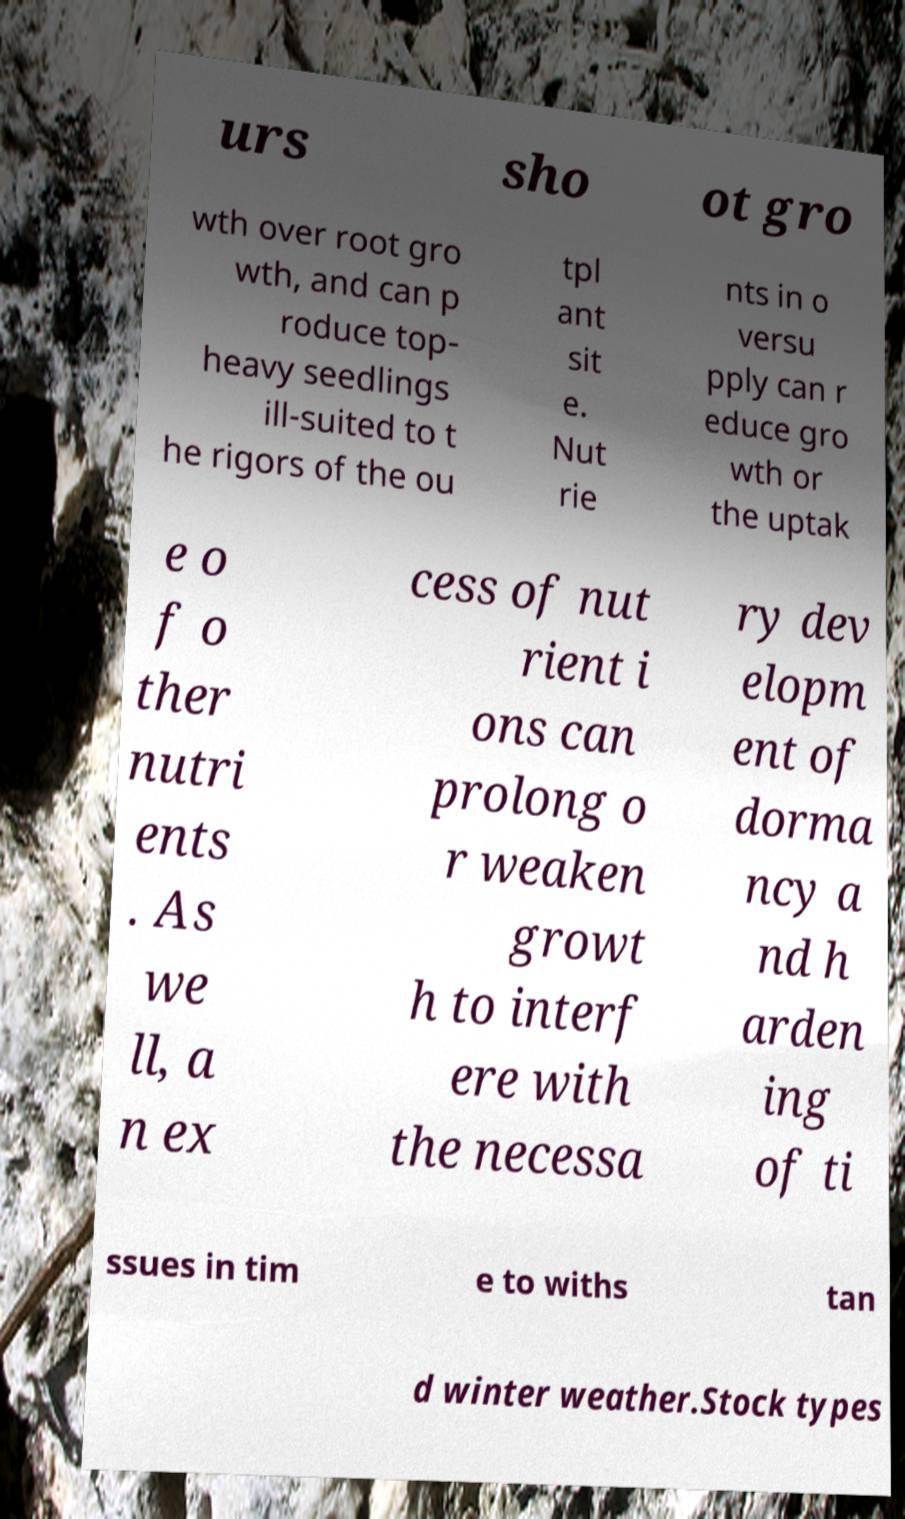I need the written content from this picture converted into text. Can you do that? urs sho ot gro wth over root gro wth, and can p roduce top- heavy seedlings ill-suited to t he rigors of the ou tpl ant sit e. Nut rie nts in o versu pply can r educe gro wth or the uptak e o f o ther nutri ents . As we ll, a n ex cess of nut rient i ons can prolong o r weaken growt h to interf ere with the necessa ry dev elopm ent of dorma ncy a nd h arden ing of ti ssues in tim e to withs tan d winter weather.Stock types 